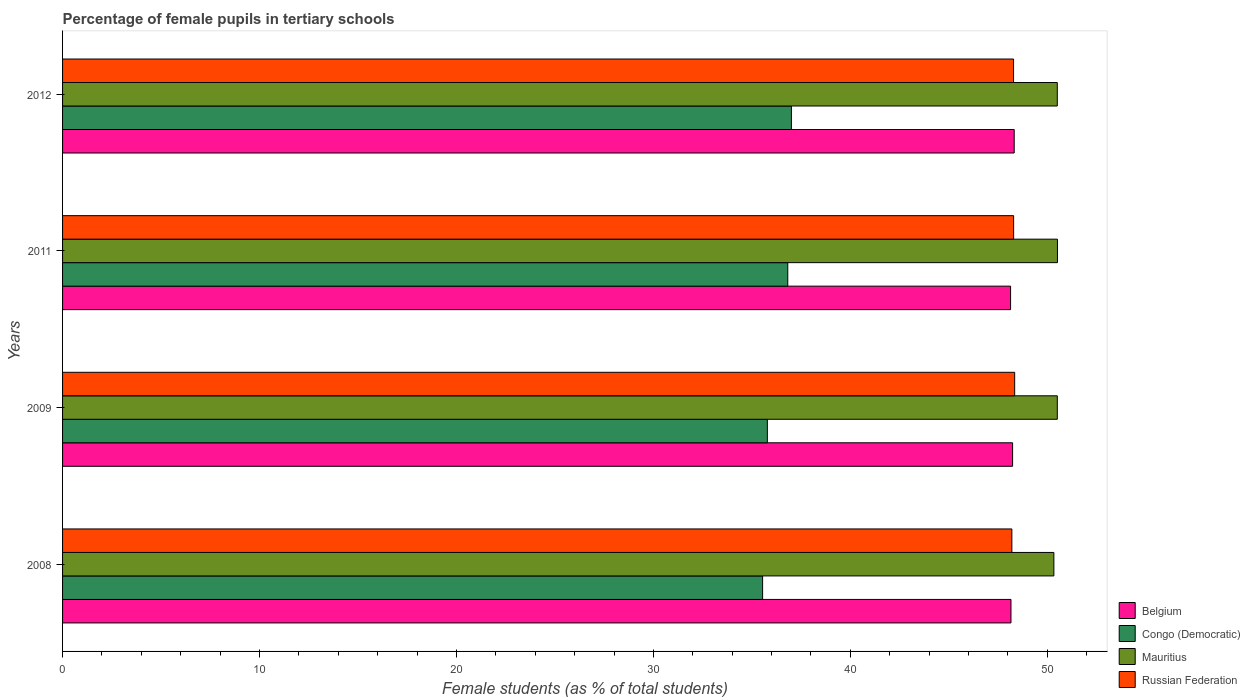How many different coloured bars are there?
Offer a very short reply. 4. Are the number of bars on each tick of the Y-axis equal?
Provide a short and direct response. Yes. What is the label of the 4th group of bars from the top?
Provide a succinct answer. 2008. What is the percentage of female pupils in tertiary schools in Russian Federation in 2012?
Provide a short and direct response. 48.29. Across all years, what is the maximum percentage of female pupils in tertiary schools in Russian Federation?
Your response must be concise. 48.34. Across all years, what is the minimum percentage of female pupils in tertiary schools in Mauritius?
Provide a succinct answer. 50.33. In which year was the percentage of female pupils in tertiary schools in Mauritius maximum?
Make the answer very short. 2011. In which year was the percentage of female pupils in tertiary schools in Russian Federation minimum?
Offer a very short reply. 2008. What is the total percentage of female pupils in tertiary schools in Russian Federation in the graph?
Offer a terse response. 193.12. What is the difference between the percentage of female pupils in tertiary schools in Belgium in 2009 and that in 2012?
Offer a very short reply. -0.08. What is the difference between the percentage of female pupils in tertiary schools in Belgium in 2011 and the percentage of female pupils in tertiary schools in Mauritius in 2008?
Your answer should be very brief. -2.2. What is the average percentage of female pupils in tertiary schools in Mauritius per year?
Provide a succinct answer. 50.47. In the year 2009, what is the difference between the percentage of female pupils in tertiary schools in Belgium and percentage of female pupils in tertiary schools in Mauritius?
Ensure brevity in your answer.  -2.27. What is the ratio of the percentage of female pupils in tertiary schools in Congo (Democratic) in 2008 to that in 2011?
Your answer should be compact. 0.97. Is the percentage of female pupils in tertiary schools in Belgium in 2008 less than that in 2011?
Offer a terse response. No. What is the difference between the highest and the second highest percentage of female pupils in tertiary schools in Russian Federation?
Your answer should be compact. 0.05. What is the difference between the highest and the lowest percentage of female pupils in tertiary schools in Congo (Democratic)?
Ensure brevity in your answer.  1.46. Is the sum of the percentage of female pupils in tertiary schools in Congo (Democratic) in 2008 and 2011 greater than the maximum percentage of female pupils in tertiary schools in Russian Federation across all years?
Provide a short and direct response. Yes. What does the 2nd bar from the top in 2012 represents?
Your answer should be very brief. Mauritius. What does the 2nd bar from the bottom in 2011 represents?
Your answer should be compact. Congo (Democratic). Is it the case that in every year, the sum of the percentage of female pupils in tertiary schools in Belgium and percentage of female pupils in tertiary schools in Congo (Democratic) is greater than the percentage of female pupils in tertiary schools in Russian Federation?
Keep it short and to the point. Yes. Are all the bars in the graph horizontal?
Provide a succinct answer. Yes. Does the graph contain any zero values?
Offer a terse response. No. How many legend labels are there?
Offer a terse response. 4. What is the title of the graph?
Ensure brevity in your answer.  Percentage of female pupils in tertiary schools. Does "Nepal" appear as one of the legend labels in the graph?
Offer a very short reply. No. What is the label or title of the X-axis?
Offer a terse response. Female students (as % of total students). What is the label or title of the Y-axis?
Offer a very short reply. Years. What is the Female students (as % of total students) in Belgium in 2008?
Offer a terse response. 48.15. What is the Female students (as % of total students) in Congo (Democratic) in 2008?
Offer a terse response. 35.54. What is the Female students (as % of total students) in Mauritius in 2008?
Keep it short and to the point. 50.33. What is the Female students (as % of total students) in Russian Federation in 2008?
Provide a succinct answer. 48.2. What is the Female students (as % of total students) in Belgium in 2009?
Offer a terse response. 48.24. What is the Female students (as % of total students) of Congo (Democratic) in 2009?
Make the answer very short. 35.79. What is the Female students (as % of total students) in Mauritius in 2009?
Your answer should be very brief. 50.51. What is the Female students (as % of total students) in Russian Federation in 2009?
Offer a terse response. 48.34. What is the Female students (as % of total students) of Belgium in 2011?
Your answer should be very brief. 48.13. What is the Female students (as % of total students) of Congo (Democratic) in 2011?
Make the answer very short. 36.82. What is the Female students (as % of total students) in Mauritius in 2011?
Offer a very short reply. 50.51. What is the Female students (as % of total students) in Russian Federation in 2011?
Make the answer very short. 48.29. What is the Female students (as % of total students) of Belgium in 2012?
Give a very brief answer. 48.32. What is the Female students (as % of total students) of Congo (Democratic) in 2012?
Your response must be concise. 37.01. What is the Female students (as % of total students) in Mauritius in 2012?
Your response must be concise. 50.51. What is the Female students (as % of total students) in Russian Federation in 2012?
Give a very brief answer. 48.29. Across all years, what is the maximum Female students (as % of total students) of Belgium?
Make the answer very short. 48.32. Across all years, what is the maximum Female students (as % of total students) of Congo (Democratic)?
Your answer should be compact. 37.01. Across all years, what is the maximum Female students (as % of total students) in Mauritius?
Provide a short and direct response. 50.51. Across all years, what is the maximum Female students (as % of total students) in Russian Federation?
Your answer should be very brief. 48.34. Across all years, what is the minimum Female students (as % of total students) in Belgium?
Your answer should be very brief. 48.13. Across all years, what is the minimum Female students (as % of total students) in Congo (Democratic)?
Offer a terse response. 35.54. Across all years, what is the minimum Female students (as % of total students) in Mauritius?
Make the answer very short. 50.33. Across all years, what is the minimum Female students (as % of total students) in Russian Federation?
Provide a short and direct response. 48.2. What is the total Female students (as % of total students) of Belgium in the graph?
Your response must be concise. 192.85. What is the total Female students (as % of total students) of Congo (Democratic) in the graph?
Your answer should be compact. 145.16. What is the total Female students (as % of total students) of Mauritius in the graph?
Keep it short and to the point. 201.86. What is the total Female students (as % of total students) of Russian Federation in the graph?
Make the answer very short. 193.12. What is the difference between the Female students (as % of total students) in Belgium in 2008 and that in 2009?
Offer a terse response. -0.08. What is the difference between the Female students (as % of total students) in Congo (Democratic) in 2008 and that in 2009?
Ensure brevity in your answer.  -0.24. What is the difference between the Female students (as % of total students) of Mauritius in 2008 and that in 2009?
Your answer should be compact. -0.17. What is the difference between the Female students (as % of total students) in Russian Federation in 2008 and that in 2009?
Provide a short and direct response. -0.14. What is the difference between the Female students (as % of total students) in Belgium in 2008 and that in 2011?
Provide a short and direct response. 0.02. What is the difference between the Female students (as % of total students) in Congo (Democratic) in 2008 and that in 2011?
Ensure brevity in your answer.  -1.28. What is the difference between the Female students (as % of total students) of Mauritius in 2008 and that in 2011?
Give a very brief answer. -0.18. What is the difference between the Female students (as % of total students) of Russian Federation in 2008 and that in 2011?
Your answer should be compact. -0.09. What is the difference between the Female students (as % of total students) of Belgium in 2008 and that in 2012?
Your response must be concise. -0.16. What is the difference between the Female students (as % of total students) in Congo (Democratic) in 2008 and that in 2012?
Provide a succinct answer. -1.46. What is the difference between the Female students (as % of total students) of Mauritius in 2008 and that in 2012?
Provide a succinct answer. -0.17. What is the difference between the Female students (as % of total students) of Russian Federation in 2008 and that in 2012?
Provide a succinct answer. -0.09. What is the difference between the Female students (as % of total students) of Belgium in 2009 and that in 2011?
Your answer should be compact. 0.1. What is the difference between the Female students (as % of total students) of Congo (Democratic) in 2009 and that in 2011?
Your answer should be very brief. -1.04. What is the difference between the Female students (as % of total students) of Mauritius in 2009 and that in 2011?
Your answer should be compact. -0.01. What is the difference between the Female students (as % of total students) in Russian Federation in 2009 and that in 2011?
Your response must be concise. 0.05. What is the difference between the Female students (as % of total students) in Belgium in 2009 and that in 2012?
Make the answer very short. -0.08. What is the difference between the Female students (as % of total students) in Congo (Democratic) in 2009 and that in 2012?
Provide a short and direct response. -1.22. What is the difference between the Female students (as % of total students) of Mauritius in 2009 and that in 2012?
Offer a very short reply. 0. What is the difference between the Female students (as % of total students) in Russian Federation in 2009 and that in 2012?
Make the answer very short. 0.06. What is the difference between the Female students (as % of total students) of Belgium in 2011 and that in 2012?
Ensure brevity in your answer.  -0.18. What is the difference between the Female students (as % of total students) of Congo (Democratic) in 2011 and that in 2012?
Ensure brevity in your answer.  -0.18. What is the difference between the Female students (as % of total students) in Mauritius in 2011 and that in 2012?
Your answer should be very brief. 0.01. What is the difference between the Female students (as % of total students) of Russian Federation in 2011 and that in 2012?
Give a very brief answer. 0. What is the difference between the Female students (as % of total students) of Belgium in 2008 and the Female students (as % of total students) of Congo (Democratic) in 2009?
Your answer should be very brief. 12.37. What is the difference between the Female students (as % of total students) in Belgium in 2008 and the Female students (as % of total students) in Mauritius in 2009?
Keep it short and to the point. -2.35. What is the difference between the Female students (as % of total students) in Belgium in 2008 and the Female students (as % of total students) in Russian Federation in 2009?
Your response must be concise. -0.19. What is the difference between the Female students (as % of total students) of Congo (Democratic) in 2008 and the Female students (as % of total students) of Mauritius in 2009?
Offer a terse response. -14.96. What is the difference between the Female students (as % of total students) in Congo (Democratic) in 2008 and the Female students (as % of total students) in Russian Federation in 2009?
Your answer should be compact. -12.8. What is the difference between the Female students (as % of total students) in Mauritius in 2008 and the Female students (as % of total students) in Russian Federation in 2009?
Your answer should be compact. 1.99. What is the difference between the Female students (as % of total students) in Belgium in 2008 and the Female students (as % of total students) in Congo (Democratic) in 2011?
Your answer should be very brief. 11.33. What is the difference between the Female students (as % of total students) of Belgium in 2008 and the Female students (as % of total students) of Mauritius in 2011?
Offer a terse response. -2.36. What is the difference between the Female students (as % of total students) of Belgium in 2008 and the Female students (as % of total students) of Russian Federation in 2011?
Your answer should be very brief. -0.14. What is the difference between the Female students (as % of total students) of Congo (Democratic) in 2008 and the Female students (as % of total students) of Mauritius in 2011?
Offer a very short reply. -14.97. What is the difference between the Female students (as % of total students) of Congo (Democratic) in 2008 and the Female students (as % of total students) of Russian Federation in 2011?
Your response must be concise. -12.75. What is the difference between the Female students (as % of total students) in Mauritius in 2008 and the Female students (as % of total students) in Russian Federation in 2011?
Your answer should be very brief. 2.04. What is the difference between the Female students (as % of total students) in Belgium in 2008 and the Female students (as % of total students) in Congo (Democratic) in 2012?
Make the answer very short. 11.15. What is the difference between the Female students (as % of total students) in Belgium in 2008 and the Female students (as % of total students) in Mauritius in 2012?
Your answer should be very brief. -2.35. What is the difference between the Female students (as % of total students) in Belgium in 2008 and the Female students (as % of total students) in Russian Federation in 2012?
Your response must be concise. -0.13. What is the difference between the Female students (as % of total students) of Congo (Democratic) in 2008 and the Female students (as % of total students) of Mauritius in 2012?
Keep it short and to the point. -14.96. What is the difference between the Female students (as % of total students) of Congo (Democratic) in 2008 and the Female students (as % of total students) of Russian Federation in 2012?
Provide a succinct answer. -12.74. What is the difference between the Female students (as % of total students) in Mauritius in 2008 and the Female students (as % of total students) in Russian Federation in 2012?
Your answer should be compact. 2.05. What is the difference between the Female students (as % of total students) of Belgium in 2009 and the Female students (as % of total students) of Congo (Democratic) in 2011?
Your answer should be very brief. 11.41. What is the difference between the Female students (as % of total students) in Belgium in 2009 and the Female students (as % of total students) in Mauritius in 2011?
Offer a terse response. -2.28. What is the difference between the Female students (as % of total students) of Belgium in 2009 and the Female students (as % of total students) of Russian Federation in 2011?
Provide a succinct answer. -0.05. What is the difference between the Female students (as % of total students) in Congo (Democratic) in 2009 and the Female students (as % of total students) in Mauritius in 2011?
Give a very brief answer. -14.73. What is the difference between the Female students (as % of total students) in Congo (Democratic) in 2009 and the Female students (as % of total students) in Russian Federation in 2011?
Give a very brief answer. -12.5. What is the difference between the Female students (as % of total students) in Mauritius in 2009 and the Female students (as % of total students) in Russian Federation in 2011?
Your answer should be very brief. 2.22. What is the difference between the Female students (as % of total students) in Belgium in 2009 and the Female students (as % of total students) in Congo (Democratic) in 2012?
Offer a terse response. 11.23. What is the difference between the Female students (as % of total students) of Belgium in 2009 and the Female students (as % of total students) of Mauritius in 2012?
Ensure brevity in your answer.  -2.27. What is the difference between the Female students (as % of total students) in Belgium in 2009 and the Female students (as % of total students) in Russian Federation in 2012?
Provide a succinct answer. -0.05. What is the difference between the Female students (as % of total students) in Congo (Democratic) in 2009 and the Female students (as % of total students) in Mauritius in 2012?
Your response must be concise. -14.72. What is the difference between the Female students (as % of total students) of Congo (Democratic) in 2009 and the Female students (as % of total students) of Russian Federation in 2012?
Provide a succinct answer. -12.5. What is the difference between the Female students (as % of total students) in Mauritius in 2009 and the Female students (as % of total students) in Russian Federation in 2012?
Provide a succinct answer. 2.22. What is the difference between the Female students (as % of total students) in Belgium in 2011 and the Female students (as % of total students) in Congo (Democratic) in 2012?
Keep it short and to the point. 11.13. What is the difference between the Female students (as % of total students) of Belgium in 2011 and the Female students (as % of total students) of Mauritius in 2012?
Your answer should be very brief. -2.37. What is the difference between the Female students (as % of total students) in Belgium in 2011 and the Female students (as % of total students) in Russian Federation in 2012?
Offer a terse response. -0.15. What is the difference between the Female students (as % of total students) of Congo (Democratic) in 2011 and the Female students (as % of total students) of Mauritius in 2012?
Your answer should be very brief. -13.68. What is the difference between the Female students (as % of total students) in Congo (Democratic) in 2011 and the Female students (as % of total students) in Russian Federation in 2012?
Give a very brief answer. -11.46. What is the difference between the Female students (as % of total students) of Mauritius in 2011 and the Female students (as % of total students) of Russian Federation in 2012?
Your answer should be compact. 2.23. What is the average Female students (as % of total students) in Belgium per year?
Your response must be concise. 48.21. What is the average Female students (as % of total students) in Congo (Democratic) per year?
Your answer should be very brief. 36.29. What is the average Female students (as % of total students) of Mauritius per year?
Your response must be concise. 50.47. What is the average Female students (as % of total students) in Russian Federation per year?
Offer a terse response. 48.28. In the year 2008, what is the difference between the Female students (as % of total students) in Belgium and Female students (as % of total students) in Congo (Democratic)?
Your answer should be compact. 12.61. In the year 2008, what is the difference between the Female students (as % of total students) in Belgium and Female students (as % of total students) in Mauritius?
Give a very brief answer. -2.18. In the year 2008, what is the difference between the Female students (as % of total students) of Belgium and Female students (as % of total students) of Russian Federation?
Give a very brief answer. -0.05. In the year 2008, what is the difference between the Female students (as % of total students) of Congo (Democratic) and Female students (as % of total students) of Mauritius?
Provide a short and direct response. -14.79. In the year 2008, what is the difference between the Female students (as % of total students) in Congo (Democratic) and Female students (as % of total students) in Russian Federation?
Your answer should be compact. -12.66. In the year 2008, what is the difference between the Female students (as % of total students) of Mauritius and Female students (as % of total students) of Russian Federation?
Give a very brief answer. 2.13. In the year 2009, what is the difference between the Female students (as % of total students) of Belgium and Female students (as % of total students) of Congo (Democratic)?
Offer a terse response. 12.45. In the year 2009, what is the difference between the Female students (as % of total students) of Belgium and Female students (as % of total students) of Mauritius?
Provide a succinct answer. -2.27. In the year 2009, what is the difference between the Female students (as % of total students) in Belgium and Female students (as % of total students) in Russian Federation?
Your response must be concise. -0.11. In the year 2009, what is the difference between the Female students (as % of total students) of Congo (Democratic) and Female students (as % of total students) of Mauritius?
Provide a short and direct response. -14.72. In the year 2009, what is the difference between the Female students (as % of total students) in Congo (Democratic) and Female students (as % of total students) in Russian Federation?
Offer a very short reply. -12.56. In the year 2009, what is the difference between the Female students (as % of total students) of Mauritius and Female students (as % of total students) of Russian Federation?
Your response must be concise. 2.16. In the year 2011, what is the difference between the Female students (as % of total students) of Belgium and Female students (as % of total students) of Congo (Democratic)?
Provide a succinct answer. 11.31. In the year 2011, what is the difference between the Female students (as % of total students) in Belgium and Female students (as % of total students) in Mauritius?
Your answer should be compact. -2.38. In the year 2011, what is the difference between the Female students (as % of total students) in Belgium and Female students (as % of total students) in Russian Federation?
Your response must be concise. -0.15. In the year 2011, what is the difference between the Female students (as % of total students) of Congo (Democratic) and Female students (as % of total students) of Mauritius?
Make the answer very short. -13.69. In the year 2011, what is the difference between the Female students (as % of total students) in Congo (Democratic) and Female students (as % of total students) in Russian Federation?
Make the answer very short. -11.47. In the year 2011, what is the difference between the Female students (as % of total students) of Mauritius and Female students (as % of total students) of Russian Federation?
Your response must be concise. 2.23. In the year 2012, what is the difference between the Female students (as % of total students) of Belgium and Female students (as % of total students) of Congo (Democratic)?
Ensure brevity in your answer.  11.31. In the year 2012, what is the difference between the Female students (as % of total students) in Belgium and Female students (as % of total students) in Mauritius?
Your response must be concise. -2.19. In the year 2012, what is the difference between the Female students (as % of total students) of Belgium and Female students (as % of total students) of Russian Federation?
Your response must be concise. 0.03. In the year 2012, what is the difference between the Female students (as % of total students) of Congo (Democratic) and Female students (as % of total students) of Mauritius?
Ensure brevity in your answer.  -13.5. In the year 2012, what is the difference between the Female students (as % of total students) of Congo (Democratic) and Female students (as % of total students) of Russian Federation?
Offer a terse response. -11.28. In the year 2012, what is the difference between the Female students (as % of total students) in Mauritius and Female students (as % of total students) in Russian Federation?
Your answer should be very brief. 2.22. What is the ratio of the Female students (as % of total students) of Russian Federation in 2008 to that in 2009?
Make the answer very short. 1. What is the ratio of the Female students (as % of total students) of Belgium in 2008 to that in 2011?
Your answer should be compact. 1. What is the ratio of the Female students (as % of total students) of Congo (Democratic) in 2008 to that in 2011?
Provide a short and direct response. 0.97. What is the ratio of the Female students (as % of total students) of Congo (Democratic) in 2008 to that in 2012?
Your answer should be compact. 0.96. What is the ratio of the Female students (as % of total students) in Mauritius in 2008 to that in 2012?
Ensure brevity in your answer.  1. What is the ratio of the Female students (as % of total students) of Russian Federation in 2008 to that in 2012?
Your answer should be compact. 1. What is the ratio of the Female students (as % of total students) of Belgium in 2009 to that in 2011?
Offer a terse response. 1. What is the ratio of the Female students (as % of total students) in Congo (Democratic) in 2009 to that in 2011?
Your answer should be very brief. 0.97. What is the ratio of the Female students (as % of total students) of Mauritius in 2009 to that in 2011?
Your answer should be compact. 1. What is the ratio of the Female students (as % of total students) of Russian Federation in 2009 to that in 2011?
Keep it short and to the point. 1. What is the ratio of the Female students (as % of total students) of Belgium in 2011 to that in 2012?
Provide a succinct answer. 1. What is the ratio of the Female students (as % of total students) of Mauritius in 2011 to that in 2012?
Provide a short and direct response. 1. What is the ratio of the Female students (as % of total students) of Russian Federation in 2011 to that in 2012?
Offer a terse response. 1. What is the difference between the highest and the second highest Female students (as % of total students) of Belgium?
Provide a short and direct response. 0.08. What is the difference between the highest and the second highest Female students (as % of total students) of Congo (Democratic)?
Your answer should be very brief. 0.18. What is the difference between the highest and the second highest Female students (as % of total students) of Mauritius?
Provide a succinct answer. 0.01. What is the difference between the highest and the second highest Female students (as % of total students) of Russian Federation?
Ensure brevity in your answer.  0.05. What is the difference between the highest and the lowest Female students (as % of total students) in Belgium?
Ensure brevity in your answer.  0.18. What is the difference between the highest and the lowest Female students (as % of total students) of Congo (Democratic)?
Offer a very short reply. 1.46. What is the difference between the highest and the lowest Female students (as % of total students) of Mauritius?
Offer a very short reply. 0.18. What is the difference between the highest and the lowest Female students (as % of total students) in Russian Federation?
Make the answer very short. 0.14. 